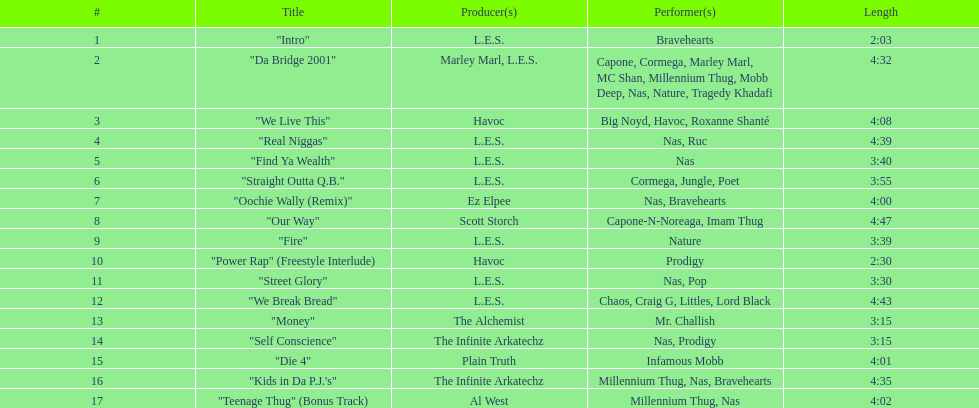What's the length of the least lengthy tune on the album? 2:03. 